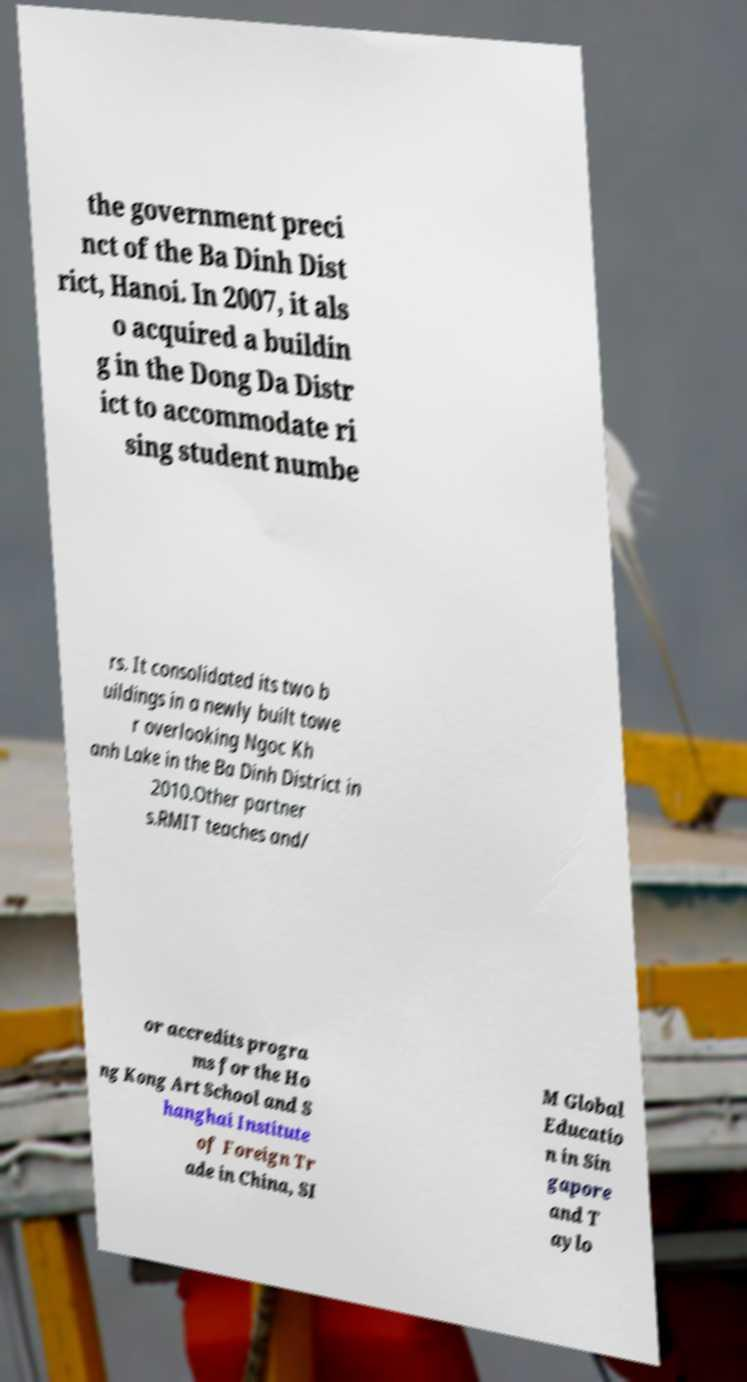Could you extract and type out the text from this image? the government preci nct of the Ba Dinh Dist rict, Hanoi. In 2007, it als o acquired a buildin g in the Dong Da Distr ict to accommodate ri sing student numbe rs. It consolidated its two b uildings in a newly built towe r overlooking Ngoc Kh anh Lake in the Ba Dinh District in 2010.Other partner s.RMIT teaches and/ or accredits progra ms for the Ho ng Kong Art School and S hanghai Institute of Foreign Tr ade in China, SI M Global Educatio n in Sin gapore and T aylo 